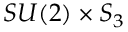Convert formula to latex. <formula><loc_0><loc_0><loc_500><loc_500>S U ( 2 ) \times S _ { 3 }</formula> 